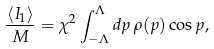<formula> <loc_0><loc_0><loc_500><loc_500>\frac { \langle I _ { 1 } \rangle } M = \chi ^ { 2 } \int _ { - \Lambda } ^ { \Lambda } d p \, \rho ( p ) \cos p ,</formula> 